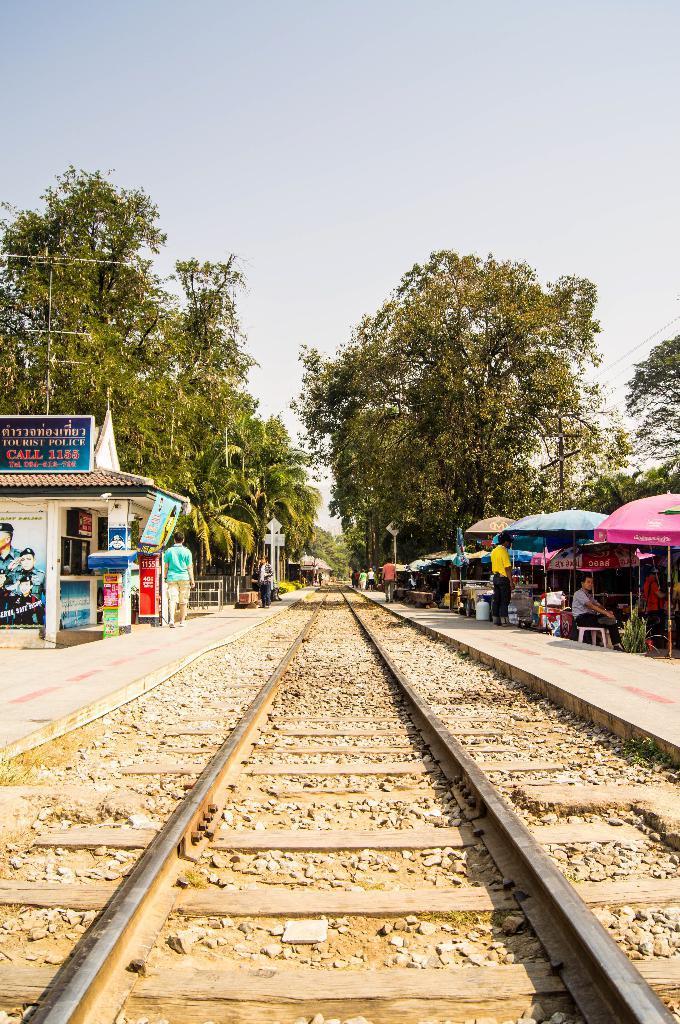In one or two sentences, can you explain what this image depicts? In the center of the image there is a railway track. On the right side of the image there are tents. There are people and there are a few objects. On the left side of the image there is a shop. There are boards. There are people. In the background of the image there are trees. There are electrical poles with cables. At the top of the image there is sky. 